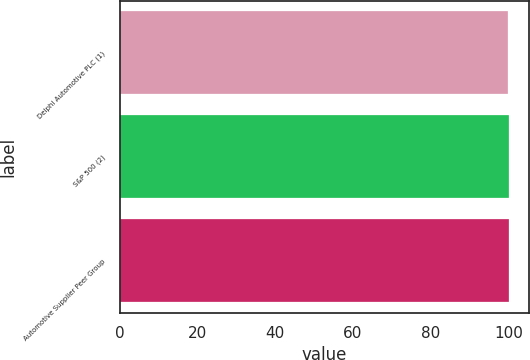Convert chart to OTSL. <chart><loc_0><loc_0><loc_500><loc_500><bar_chart><fcel>Delphi Automotive PLC (1)<fcel>S&P 500 (2)<fcel>Automotive Supplier Peer Group<nl><fcel>100<fcel>100.1<fcel>100.2<nl></chart> 